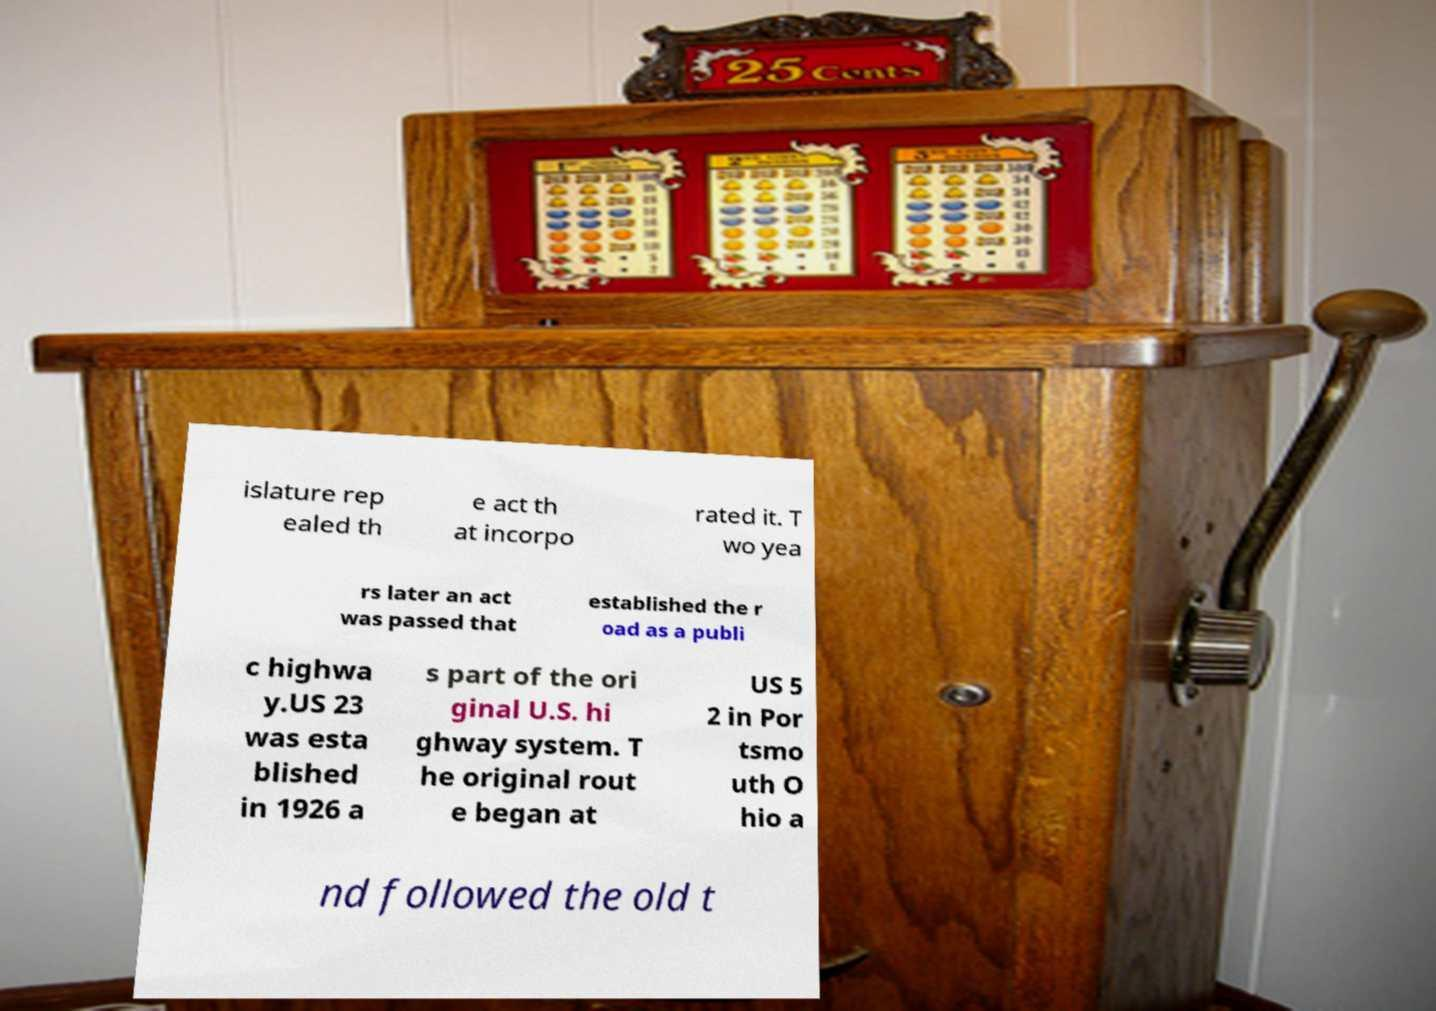For documentation purposes, I need the text within this image transcribed. Could you provide that? islature rep ealed th e act th at incorpo rated it. T wo yea rs later an act was passed that established the r oad as a publi c highwa y.US 23 was esta blished in 1926 a s part of the ori ginal U.S. hi ghway system. T he original rout e began at US 5 2 in Por tsmo uth O hio a nd followed the old t 